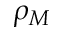<formula> <loc_0><loc_0><loc_500><loc_500>\rho _ { M }</formula> 